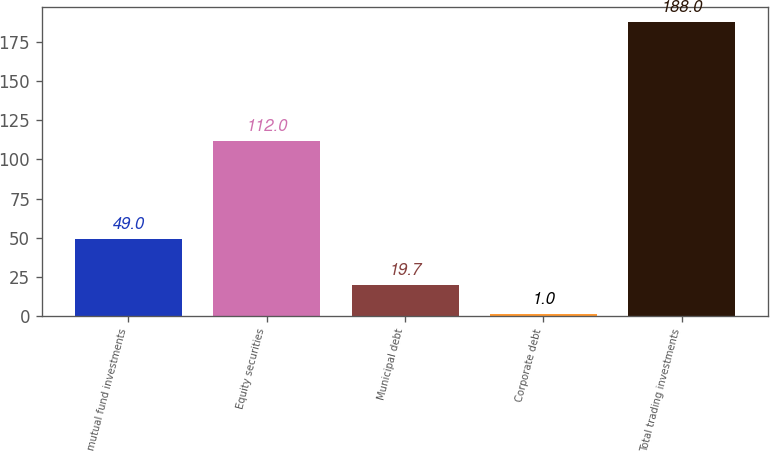<chart> <loc_0><loc_0><loc_500><loc_500><bar_chart><fcel>mutual fund investments<fcel>Equity securities<fcel>Municipal debt<fcel>Corporate debt<fcel>Total trading investments<nl><fcel>49<fcel>112<fcel>19.7<fcel>1<fcel>188<nl></chart> 